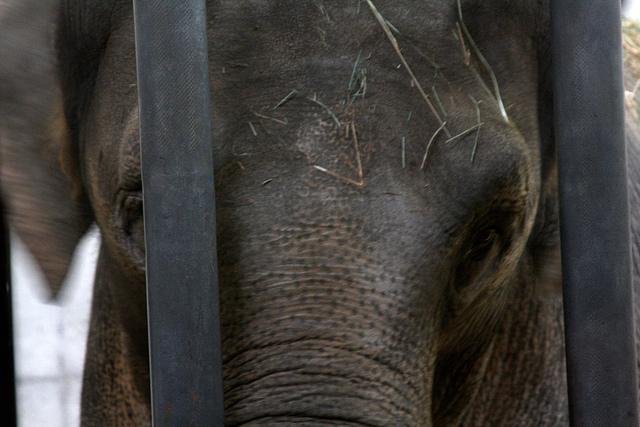Is the animal in a cage?
Concise answer only. Yes. What kind of animal is this?
Be succinct. Elephant. Are there pieces of grass on its face?
Be succinct. Yes. Is the elephant crying?
Answer briefly. No. How many animals are in the picture?
Write a very short answer. 1. 